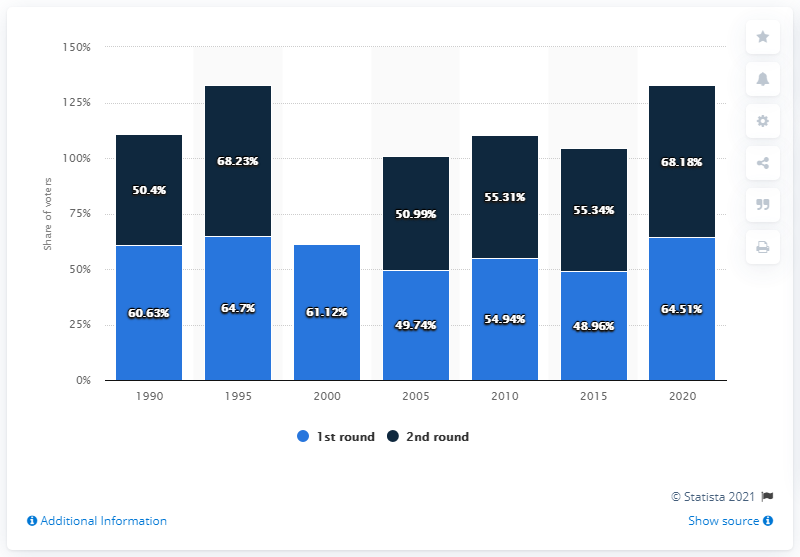List a handful of essential elements in this visual. The turnout in the second round of the presidential election was 68.18%. The voter turnout during the presidential election in Poland was 64.51%. 